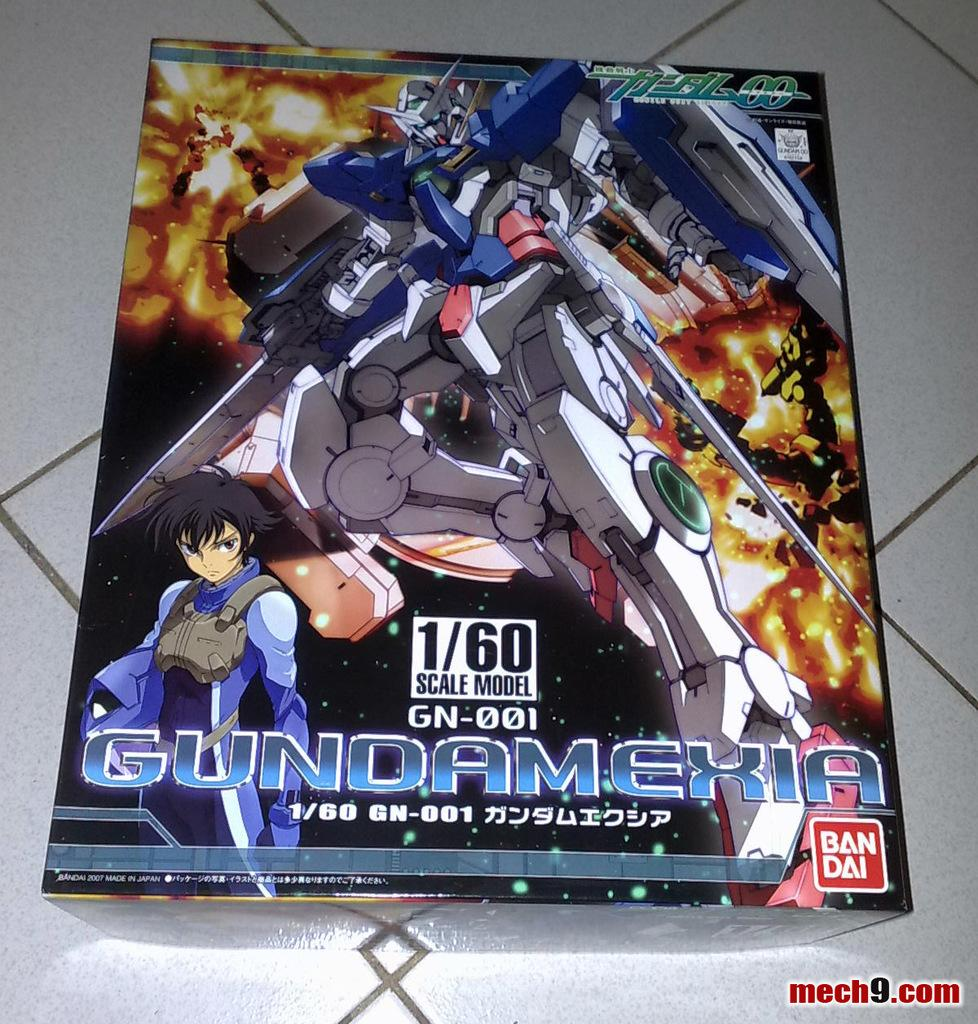<image>
Relay a brief, clear account of the picture shown. A 1/60 scale model of a character from a foreign game. 